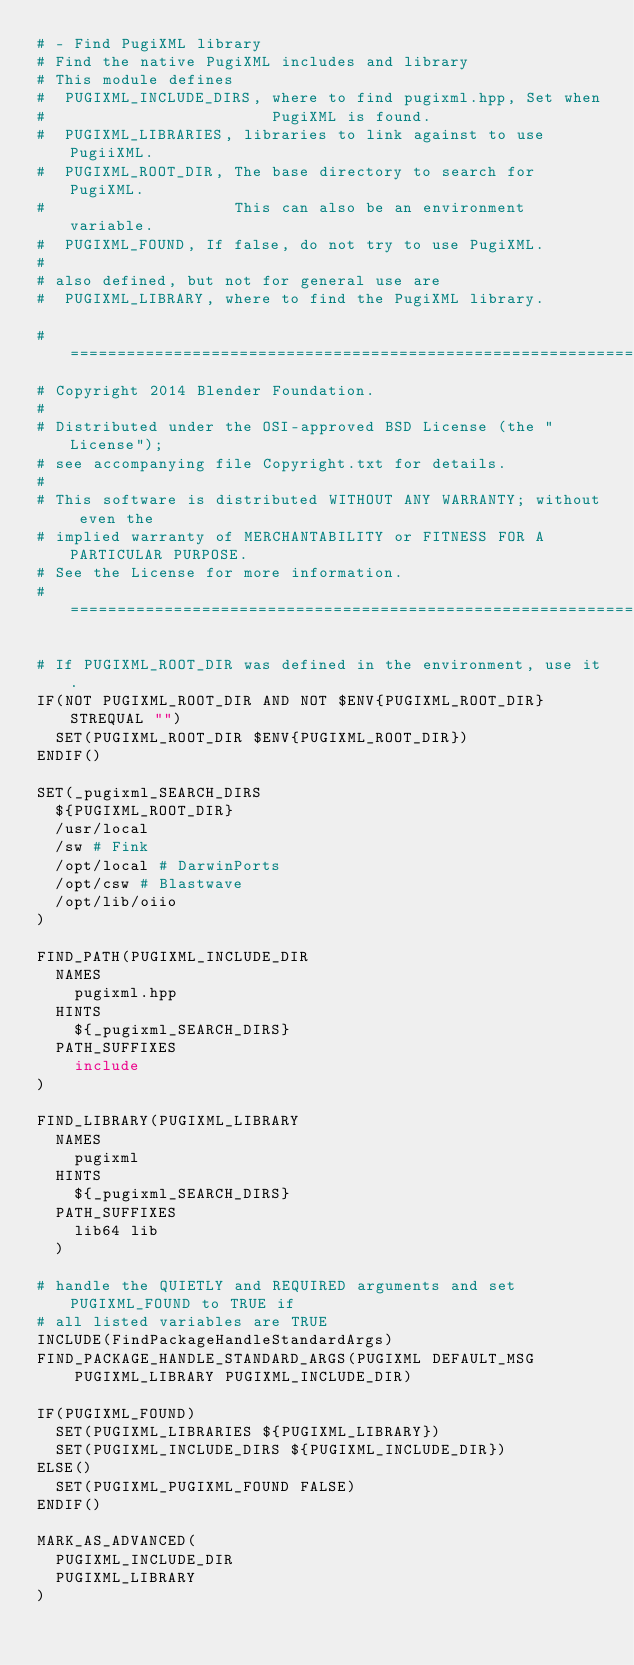Convert code to text. <code><loc_0><loc_0><loc_500><loc_500><_CMake_># - Find PugiXML library
# Find the native PugiXML includes and library
# This module defines
#  PUGIXML_INCLUDE_DIRS, where to find pugixml.hpp, Set when
#                        PugiXML is found.
#  PUGIXML_LIBRARIES, libraries to link against to use PugiiXML.
#  PUGIXML_ROOT_DIR, The base directory to search for PugiXML.
#                    This can also be an environment variable.
#  PUGIXML_FOUND, If false, do not try to use PugiXML.
#
# also defined, but not for general use are
#  PUGIXML_LIBRARY, where to find the PugiXML library.

#=============================================================================
# Copyright 2014 Blender Foundation.
#
# Distributed under the OSI-approved BSD License (the "License");
# see accompanying file Copyright.txt for details.
#
# This software is distributed WITHOUT ANY WARRANTY; without even the
# implied warranty of MERCHANTABILITY or FITNESS FOR A PARTICULAR PURPOSE.
# See the License for more information.
#=============================================================================

# If PUGIXML_ROOT_DIR was defined in the environment, use it.
IF(NOT PUGIXML_ROOT_DIR AND NOT $ENV{PUGIXML_ROOT_DIR} STREQUAL "")
  SET(PUGIXML_ROOT_DIR $ENV{PUGIXML_ROOT_DIR})
ENDIF()

SET(_pugixml_SEARCH_DIRS
  ${PUGIXML_ROOT_DIR}
  /usr/local
  /sw # Fink
  /opt/local # DarwinPorts
  /opt/csw # Blastwave
  /opt/lib/oiio
)

FIND_PATH(PUGIXML_INCLUDE_DIR
  NAMES
    pugixml.hpp
  HINTS
    ${_pugixml_SEARCH_DIRS}
  PATH_SUFFIXES
    include
)

FIND_LIBRARY(PUGIXML_LIBRARY
  NAMES
    pugixml
  HINTS
    ${_pugixml_SEARCH_DIRS}
  PATH_SUFFIXES
    lib64 lib
  )

# handle the QUIETLY and REQUIRED arguments and set PUGIXML_FOUND to TRUE if 
# all listed variables are TRUE
INCLUDE(FindPackageHandleStandardArgs)
FIND_PACKAGE_HANDLE_STANDARD_ARGS(PUGIXML DEFAULT_MSG
    PUGIXML_LIBRARY PUGIXML_INCLUDE_DIR)

IF(PUGIXML_FOUND)
  SET(PUGIXML_LIBRARIES ${PUGIXML_LIBRARY})
  SET(PUGIXML_INCLUDE_DIRS ${PUGIXML_INCLUDE_DIR})
ELSE()
  SET(PUGIXML_PUGIXML_FOUND FALSE)
ENDIF()

MARK_AS_ADVANCED(
  PUGIXML_INCLUDE_DIR
  PUGIXML_LIBRARY
)
</code> 